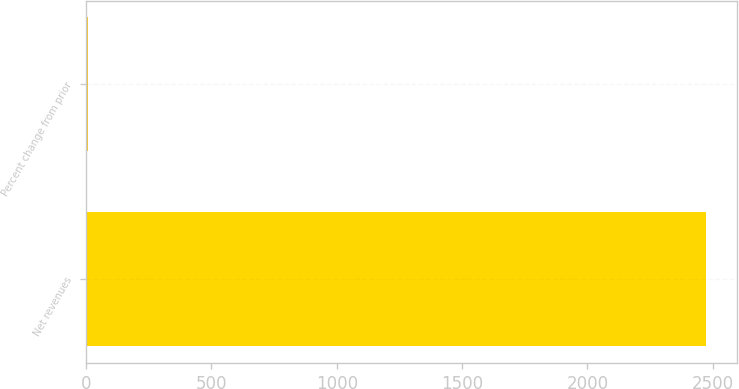Convert chart. <chart><loc_0><loc_0><loc_500><loc_500><bar_chart><fcel>Net revenues<fcel>Percent change from prior<nl><fcel>2474<fcel>8<nl></chart> 